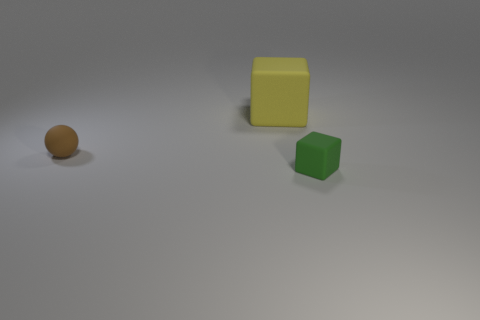Add 1 tiny metallic cylinders. How many objects exist? 4 Subtract all balls. How many objects are left? 2 Add 3 large yellow cubes. How many large yellow cubes are left? 4 Add 3 rubber blocks. How many rubber blocks exist? 5 Subtract 0 yellow spheres. How many objects are left? 3 Subtract all green matte blocks. Subtract all rubber spheres. How many objects are left? 1 